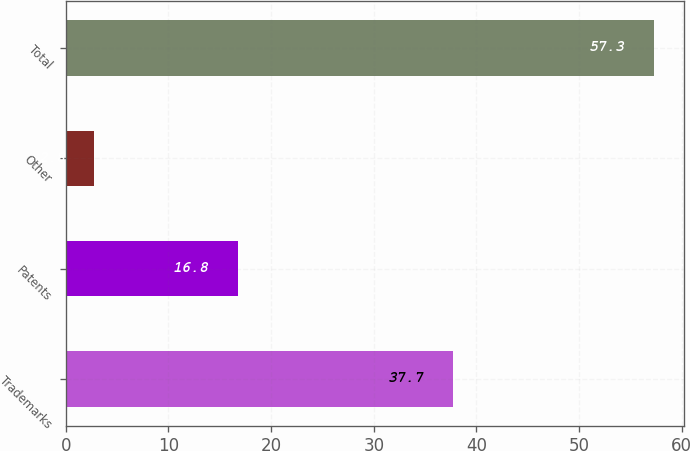<chart> <loc_0><loc_0><loc_500><loc_500><bar_chart><fcel>Trademarks<fcel>Patents<fcel>Other<fcel>Total<nl><fcel>37.7<fcel>16.8<fcel>2.8<fcel>57.3<nl></chart> 